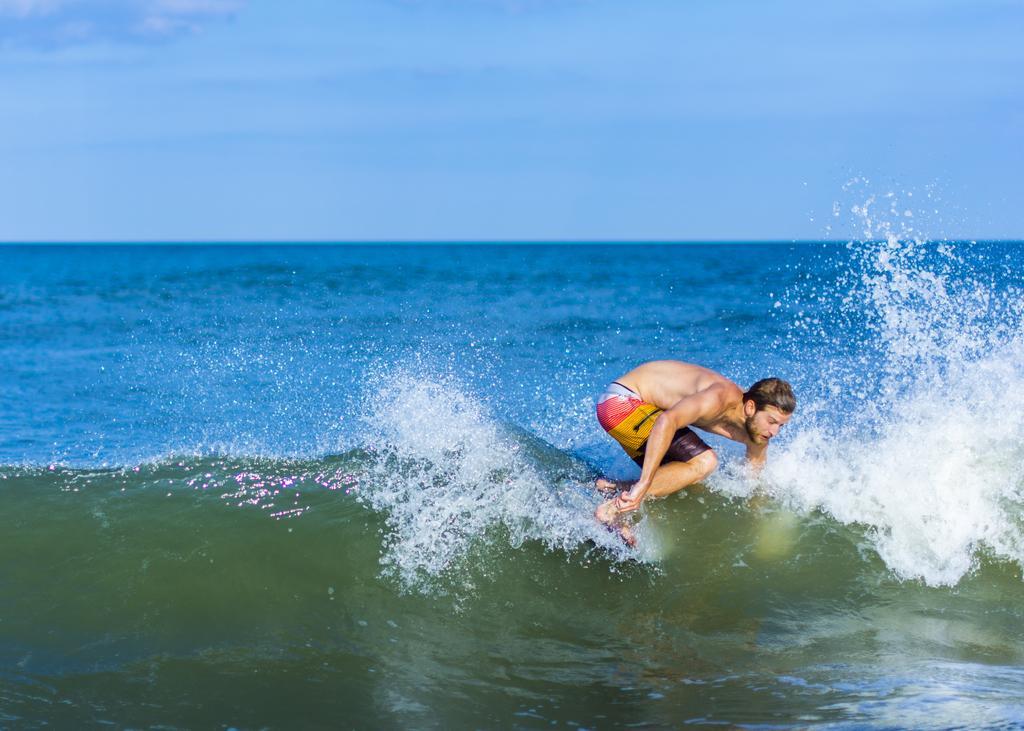Describe this image in one or two sentences. In this image we can see a person surfing on the surface of the water. We can also see the sky in the background. 